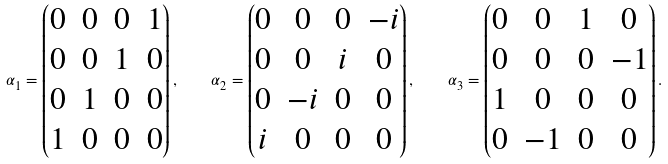<formula> <loc_0><loc_0><loc_500><loc_500>\alpha _ { 1 } = \begin{pmatrix} 0 & 0 & 0 & 1 \\ 0 & 0 & 1 & 0 \\ 0 & 1 & 0 & 0 \\ 1 & 0 & 0 & 0 \end{pmatrix} , \quad \alpha _ { 2 } = \begin{pmatrix} 0 & 0 & 0 & - i \\ 0 & 0 & i & 0 \\ 0 & - i & 0 & 0 \\ i & 0 & 0 & 0 \end{pmatrix} , \quad \alpha _ { 3 } = \begin{pmatrix} 0 & 0 & 1 & 0 \\ 0 & 0 & 0 & - 1 \\ 1 & 0 & 0 & 0 \\ 0 & - 1 & 0 & 0 \end{pmatrix} .</formula> 